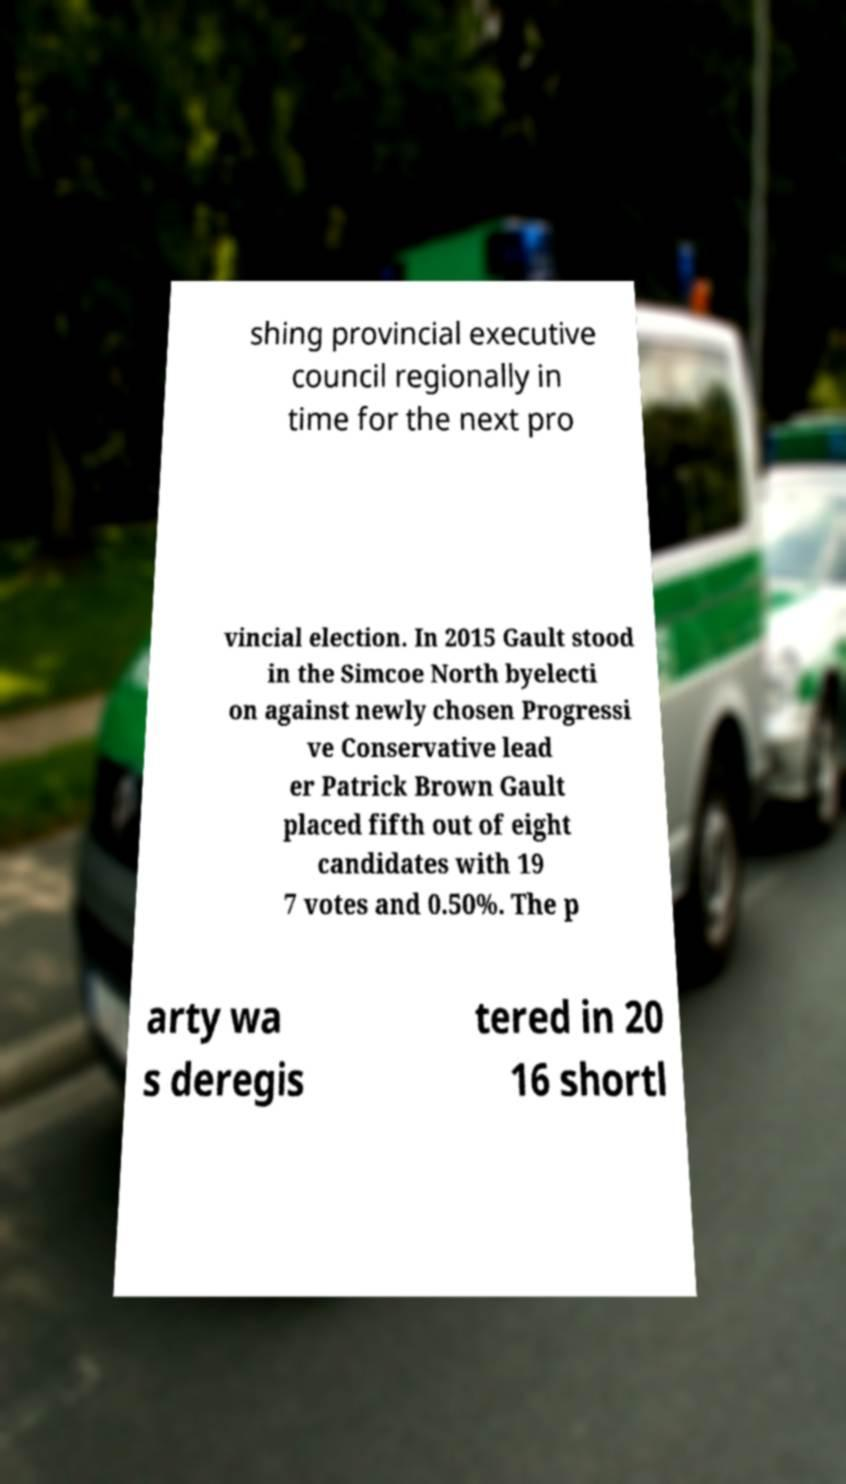Can you accurately transcribe the text from the provided image for me? shing provincial executive council regionally in time for the next pro vincial election. In 2015 Gault stood in the Simcoe North byelecti on against newly chosen Progressi ve Conservative lead er Patrick Brown Gault placed fifth out of eight candidates with 19 7 votes and 0.50%. The p arty wa s deregis tered in 20 16 shortl 